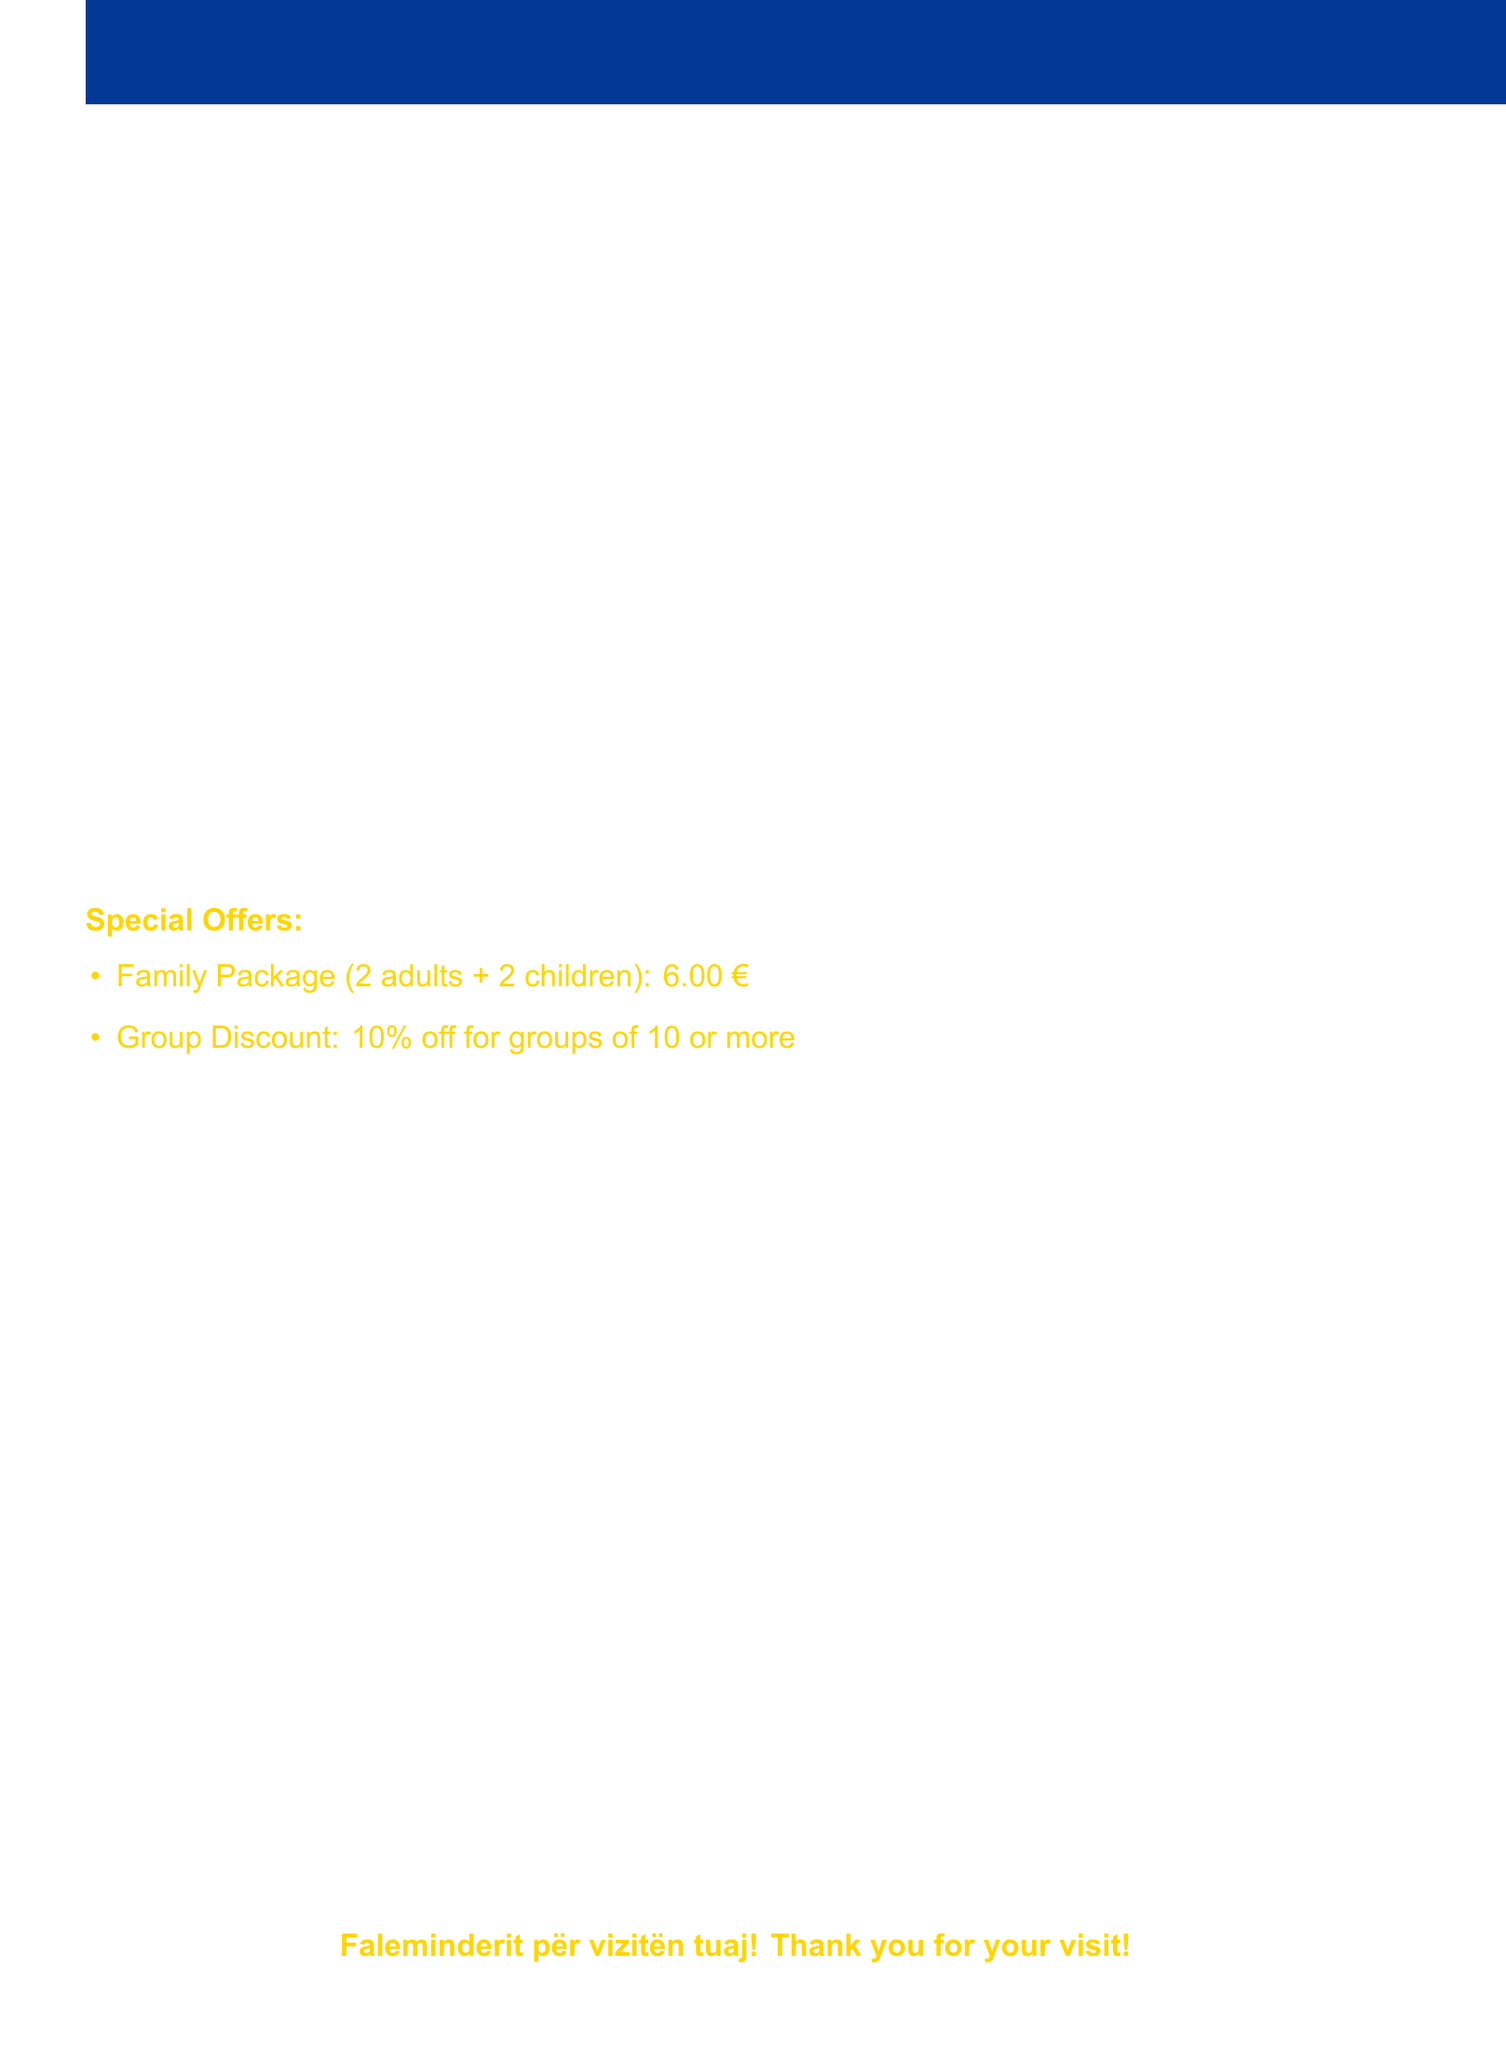What is the ticket price for adults? The document specifies that the price for adult tickets is 2.50 €.
Answer: 2.50 € What are the free entry categories? The document lists three groups that can enter for free: Children under 6, People with disabilities, and Kosovo war veterans.
Answer: Children under 6, People with disabilities, Kosovo war veterans What is included in the Family Package? The Family Package is described as valid for 2 adults and 2 children.
Answer: 2 adults + 2 children What is the opening day of the museum? The document states that the museum operates from Tuesday to Sunday.
Answer: Tuesday to Sunday How much is the Student ticket? The ticket price for students is explicitly stated in the document as 1.50 €.
Answer: 1.50 € What payment methods are accepted? The document lists the accepted payment methods which include Cash (Euro), Credit Card, and Debit Card.
Answer: Cash (Euro), Credit Card, Debit Card What is the VAT percentage included in the ticket prices? The document mentions that VAT is included at a rate of 18%.
Answer: 18% What nearby attraction is mentioned? The document lists the National Museum of Kosovo as one of the nearby attractions.
Answer: National Museum of Kosovo 